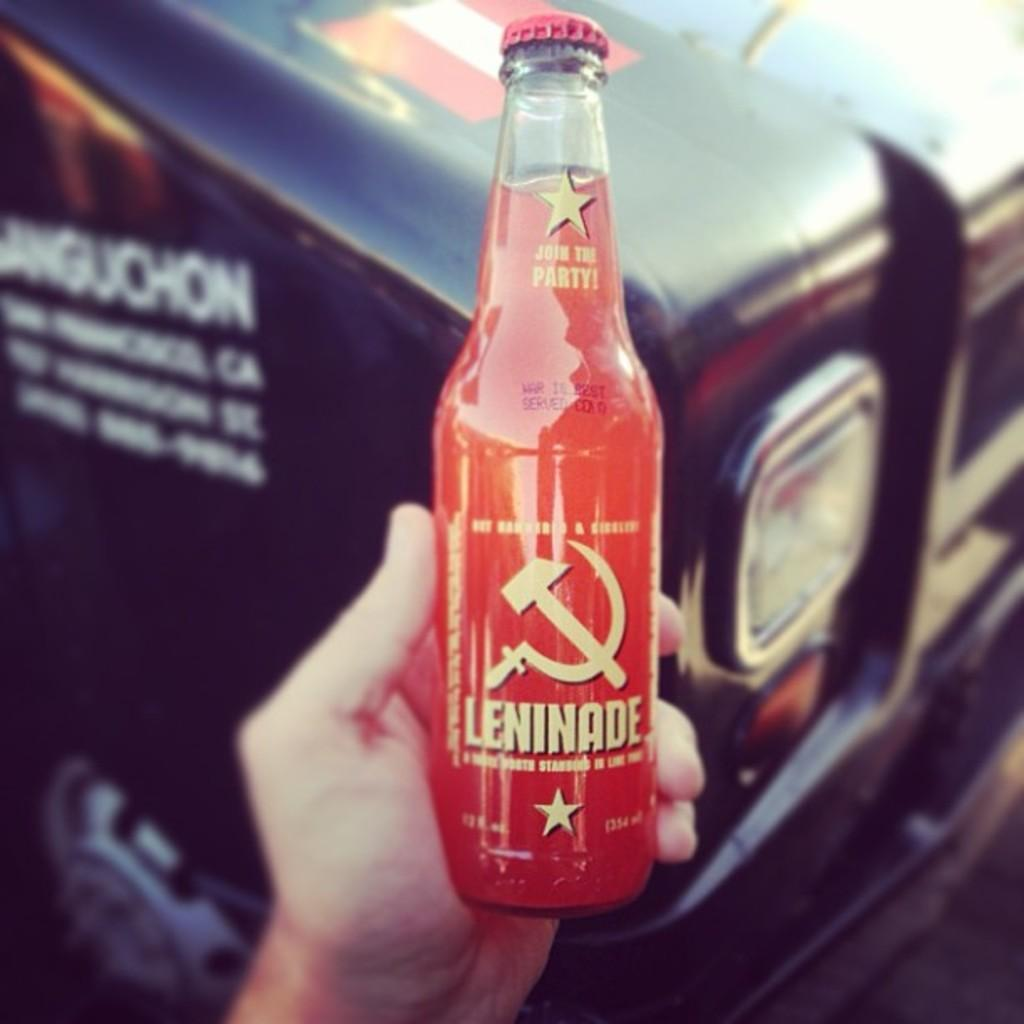What is in the bottle that is visible in the image? The bottle contains juice. What is the name of the juice brand in the image? The word "Leninade" is written on the bottle. Who is holding the bottle in the image? A hand is holding the bottle in the image. What type of stone can be seen in the image? There is no stone present in the image. How many lizards are visible in the image? There are no lizards present in the image. 